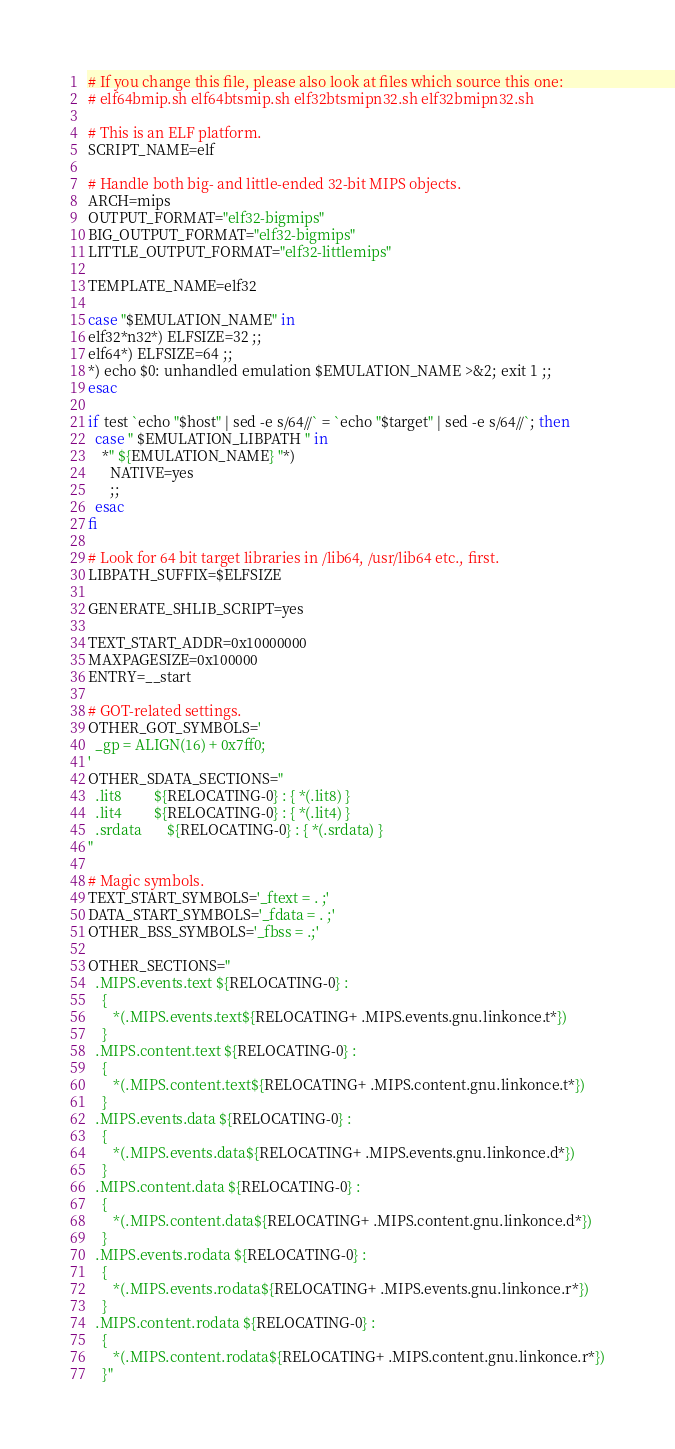Convert code to text. <code><loc_0><loc_0><loc_500><loc_500><_Bash_># If you change this file, please also look at files which source this one:
# elf64bmip.sh elf64btsmip.sh elf32btsmipn32.sh elf32bmipn32.sh

# This is an ELF platform.
SCRIPT_NAME=elf

# Handle both big- and little-ended 32-bit MIPS objects.
ARCH=mips
OUTPUT_FORMAT="elf32-bigmips"
BIG_OUTPUT_FORMAT="elf32-bigmips"
LITTLE_OUTPUT_FORMAT="elf32-littlemips"

TEMPLATE_NAME=elf32

case "$EMULATION_NAME" in
elf32*n32*) ELFSIZE=32 ;;
elf64*) ELFSIZE=64 ;;
*) echo $0: unhandled emulation $EMULATION_NAME >&2; exit 1 ;;
esac

if test `echo "$host" | sed -e s/64//` = `echo "$target" | sed -e s/64//`; then
  case " $EMULATION_LIBPATH " in
    *" ${EMULATION_NAME} "*)
      NATIVE=yes
      ;;
  esac
fi

# Look for 64 bit target libraries in /lib64, /usr/lib64 etc., first.
LIBPATH_SUFFIX=$ELFSIZE

GENERATE_SHLIB_SCRIPT=yes

TEXT_START_ADDR=0x10000000
MAXPAGESIZE=0x100000
ENTRY=__start

# GOT-related settings.  
OTHER_GOT_SYMBOLS='
  _gp = ALIGN(16) + 0x7ff0;
'
OTHER_SDATA_SECTIONS="
  .lit8         ${RELOCATING-0} : { *(.lit8) }
  .lit4         ${RELOCATING-0} : { *(.lit4) }
  .srdata       ${RELOCATING-0} : { *(.srdata) }
"

# Magic symbols.
TEXT_START_SYMBOLS='_ftext = . ;'
DATA_START_SYMBOLS='_fdata = . ;'
OTHER_BSS_SYMBOLS='_fbss = .;'

OTHER_SECTIONS="
  .MIPS.events.text ${RELOCATING-0} :
    {
       *(.MIPS.events.text${RELOCATING+ .MIPS.events.gnu.linkonce.t*})
    }
  .MIPS.content.text ${RELOCATING-0} : 
    {
       *(.MIPS.content.text${RELOCATING+ .MIPS.content.gnu.linkonce.t*})
    }
  .MIPS.events.data ${RELOCATING-0} :
    {
       *(.MIPS.events.data${RELOCATING+ .MIPS.events.gnu.linkonce.d*})
    }
  .MIPS.content.data ${RELOCATING-0} :
    {
       *(.MIPS.content.data${RELOCATING+ .MIPS.content.gnu.linkonce.d*})
    }
  .MIPS.events.rodata ${RELOCATING-0} :
    {
       *(.MIPS.events.rodata${RELOCATING+ .MIPS.events.gnu.linkonce.r*})
    }
  .MIPS.content.rodata ${RELOCATING-0} :
    {
       *(.MIPS.content.rodata${RELOCATING+ .MIPS.content.gnu.linkonce.r*})
    }"
</code> 